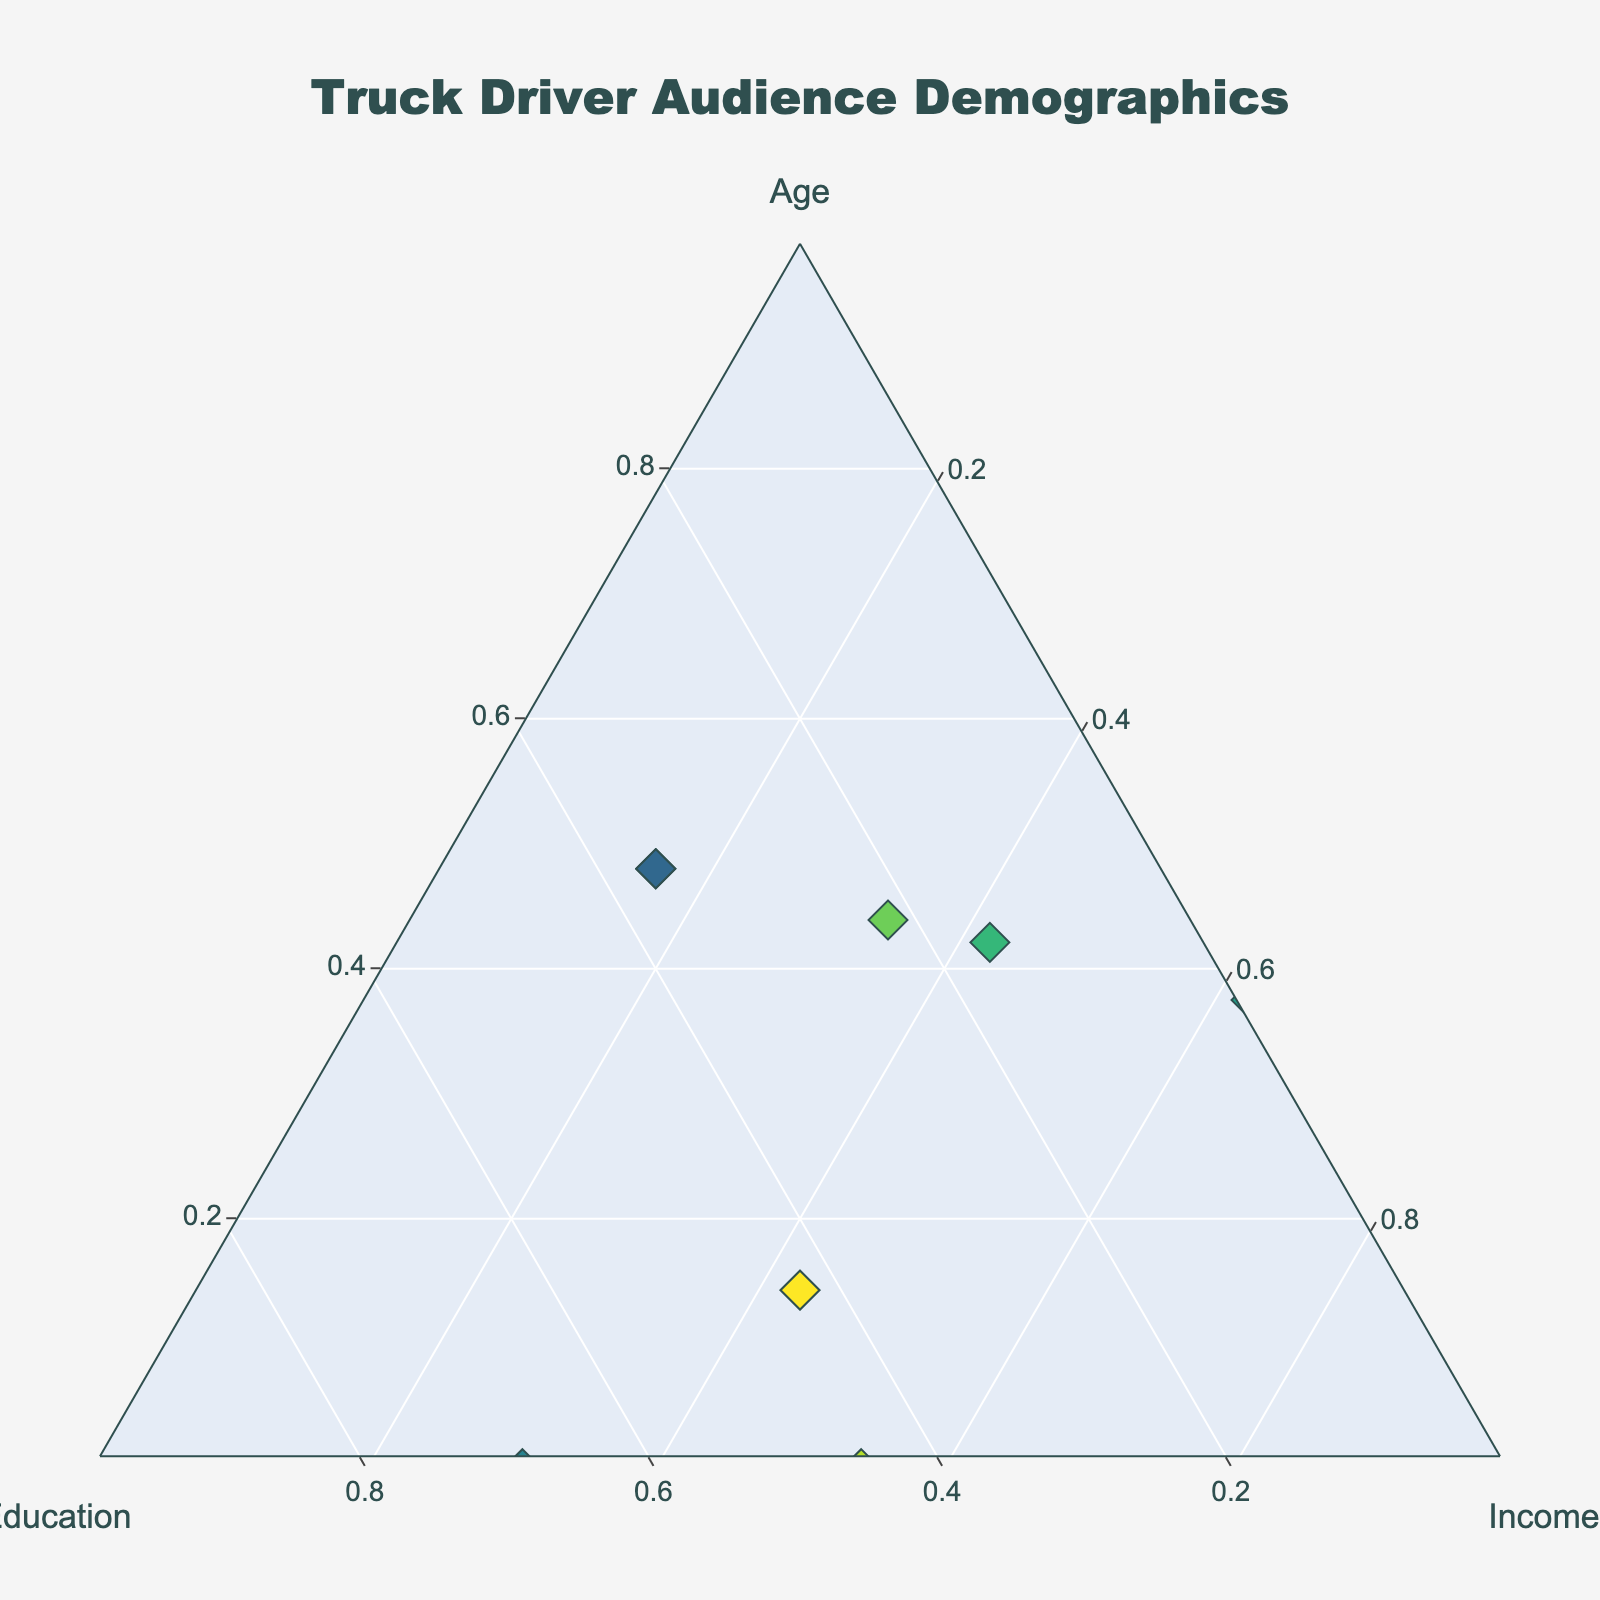How many age groups are represented in the plot? The title of the plot mentions "Truck Driver Audience Demographics," and reviewing the hover texts, we see references to multiple distinct age groups: "45-54," "35-44," "55-64," "25-34." This totals to four different age groups.
Answer: Four What is the shape and color scheme of the markers in the ternary plot? From the visual aspects of the figure, the markers are diamond-shaped with a color scale that transitions through shades in the 'Viridis' color scheme.
Answer: Diamond-shaped, 'Viridis' color scale Which age group has the highest income bracket representation, and what is that bracket? By observing the hover information over the data points, we can see that the age group "45-54" includes a data point with the heading "Income: 80k-105k," which is the highest income bracket represented.
Answer: 45-54; 80k-105k Compare the education levels of the age groups 35-44 and 25-34. Which has a higher representation of higher education? Looking at the hover details for the age groups "35-44" and "25-34," age group "35-44" includes "Bachelor's Degree" and "Trade School," while "25-34" includes "Bachelor's Degree" and "Some College." In terms of higher education levels, both have one representation of a Bachelor's Degree, while "Some College" is not considered higher than a Trade School.
Answer: 35-44; higher education representation due to Trade School inclusion What is the minimum income range for the "55-64" age group? Upon examining the hover text details for the age group "55-64," the minimum income range represented is "40k-60k."
Answer: 40k-60k Which age group has a data point represented at the highest combination of the normalized age and income axis? By examining the data points in the ternary plot and considering the highest normalized values on both the age and income axes, the data point for the age group "45-54" with "Income: 80k-105k" appears at the highest position.
Answer: 45-54 For the age group "25-34," which education levels are present and what are their income brackets? Reviewing the hover texts for the age group "25-34" reveals two education levels: "Bachelor's Degree" with the income bracket "60k-85k" and "Some College" with the income bracket "35k-55k."
Answer: Bachelor's Degree: 60k-85k; Some College: 35k-55k 